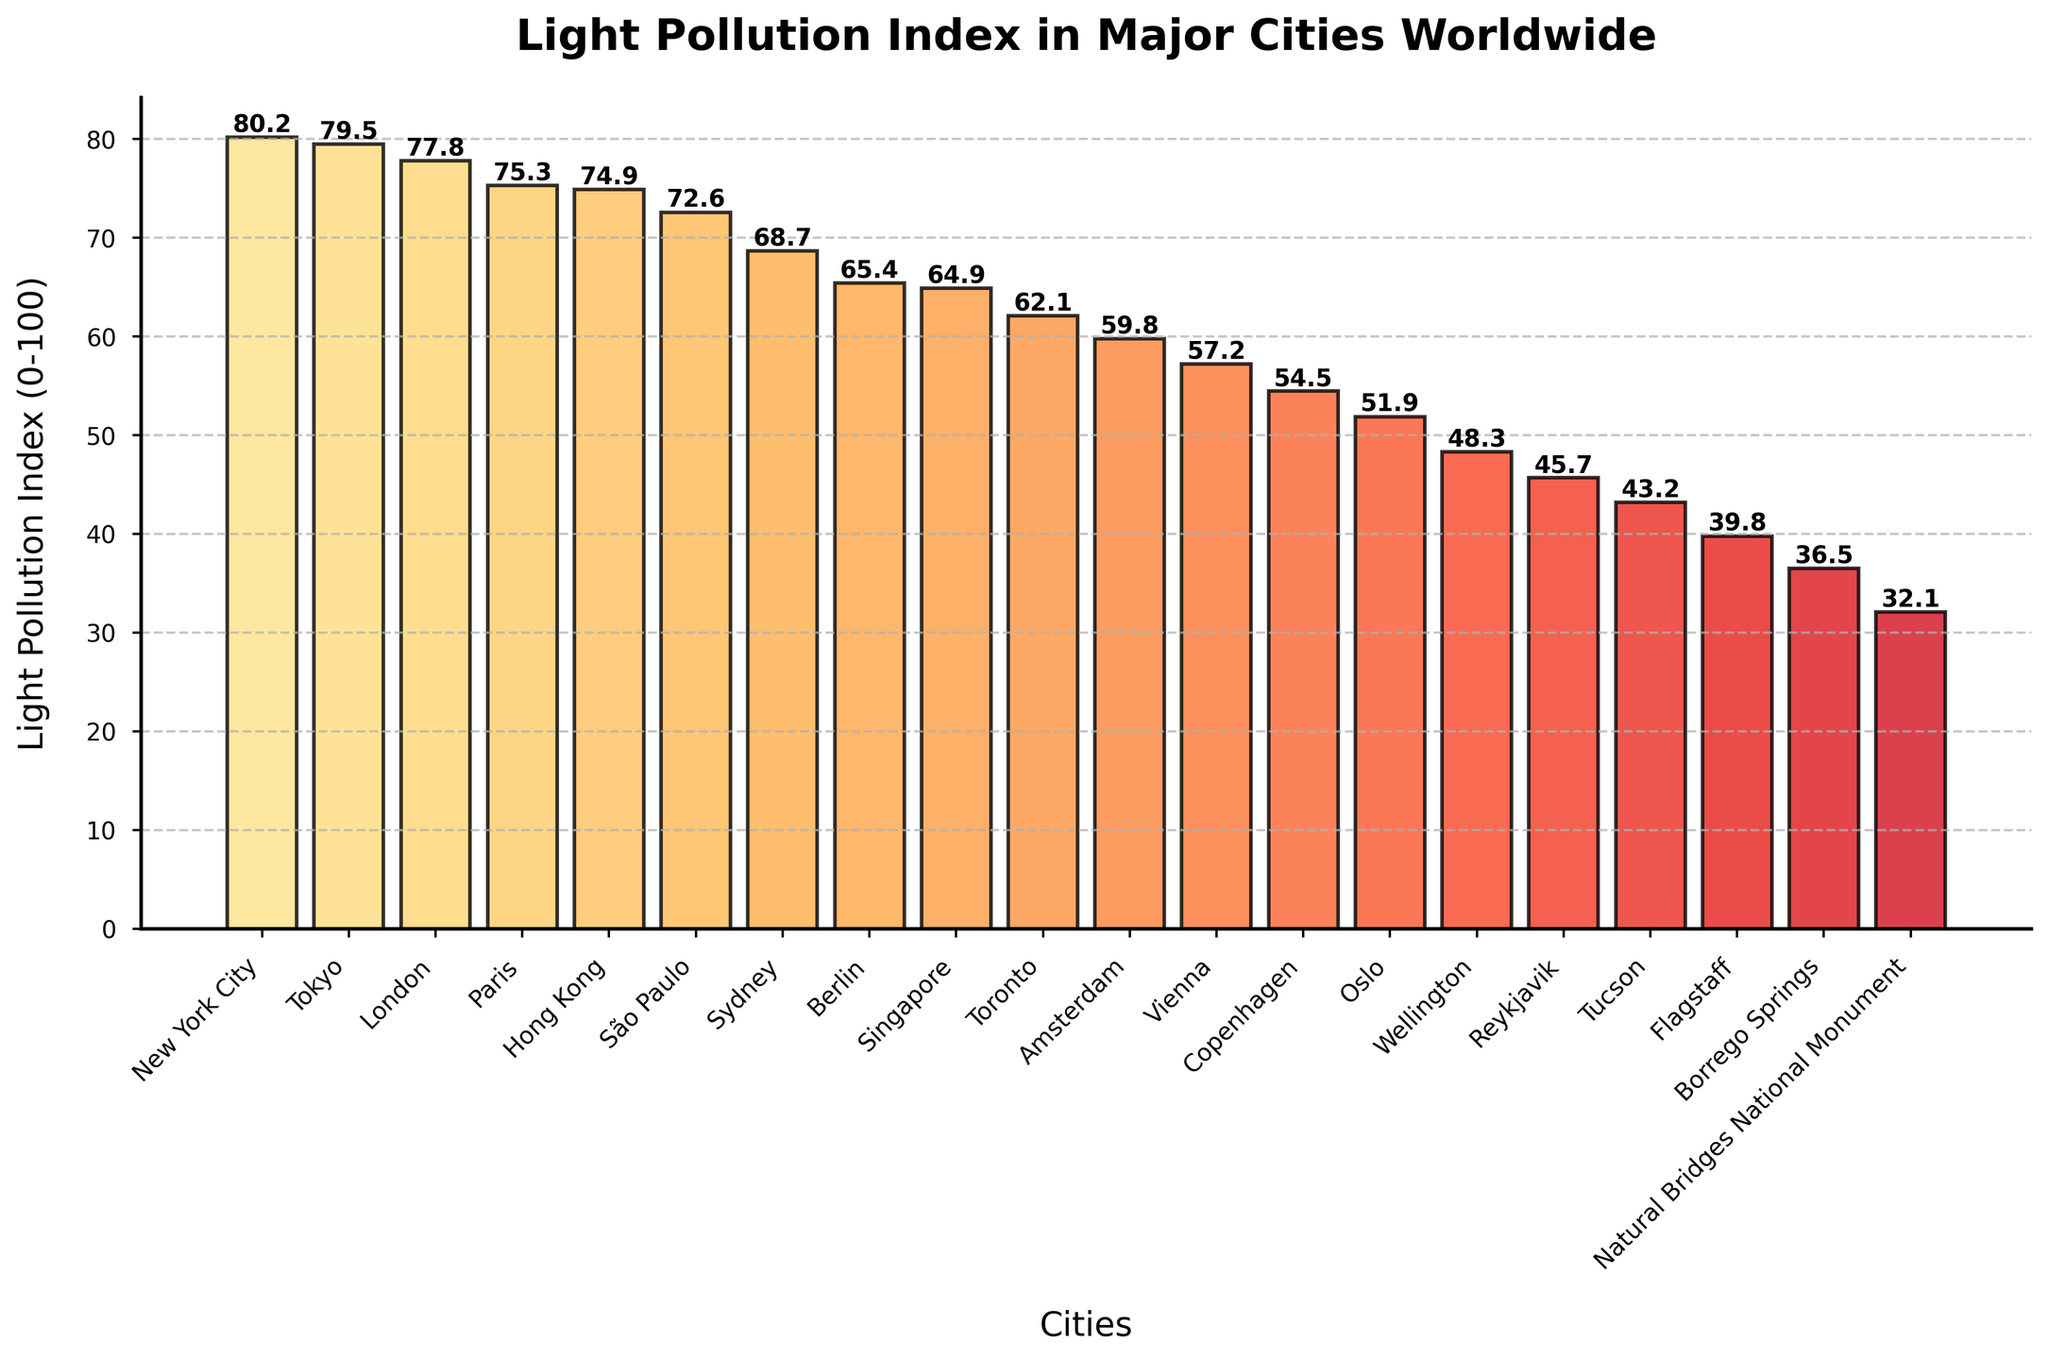Which city has the highest light pollution index? The bar representing New York City is the tallest among all cities in the plot, indicating that it has the highest light pollution index.
Answer: New York City What is the difference in the light pollution index between Paris and Tokyo? Paris has a light pollution index of 75.3, and Tokyo has a light pollution index of 79.5. Subtracting the index of Paris from Tokyo's gives 79.5 - 75.3 = 4.2.
Answer: 4.2 Which city has a lower light pollution index, Toronto or Sydney? The bar for Toronto is shorter than the bar for Sydney, indicating a lower light pollution index. Toronto has an index of 62.1 and Sydney has an index of 68.7.
Answer: Toronto What is the average light pollution index for New York City, Tokyo, and London? The light pollution indices are 80.2 (New York City), 79.5 (Tokyo), and 77.8 (London). Summing them up gives 80.2 + 79.5 + 77.8 = 237.5. Dividing by 3 yields an average of 237.5 / 3 = 79.2.
Answer: 79.2 Which city has the lowest light pollution index? The shortest bar represents the city with the lowest index, which is Natural Bridges National Monument with a light pollution index of 32.1.
Answer: Natural Bridges National Monument Order the cities Berlin, Singapore, and Sydney by their light pollution indices from highest to lowest. Berlin has a light pollution index of 65.4, Singapore has 64.9, and Sydney has 68.7. Arranging them from highest to lowest gives Sydney, Berlin, Singapore.
Answer: Sydney, Berlin, Singapore What is the sum of the light pollution indices for the cities with the top 3 highest values? The top 3 cities are New York City (80.2), Tokyo (79.5), and London (77.8). Summing these values gives 80.2 + 79.5 + 77.8 = 237.5.
Answer: 237.5 Which city is the median city in terms of light pollution index in this dataset? There are 20 cities. The median city is the one at position 10.5, so we take the average of the indices for the 10th (Toronto, 62.1) and 11th (Amsterdam, 59.8) cities. The median is thus (62.1 + 59.8) / 2 = 60.95.
Answer: 60.95 